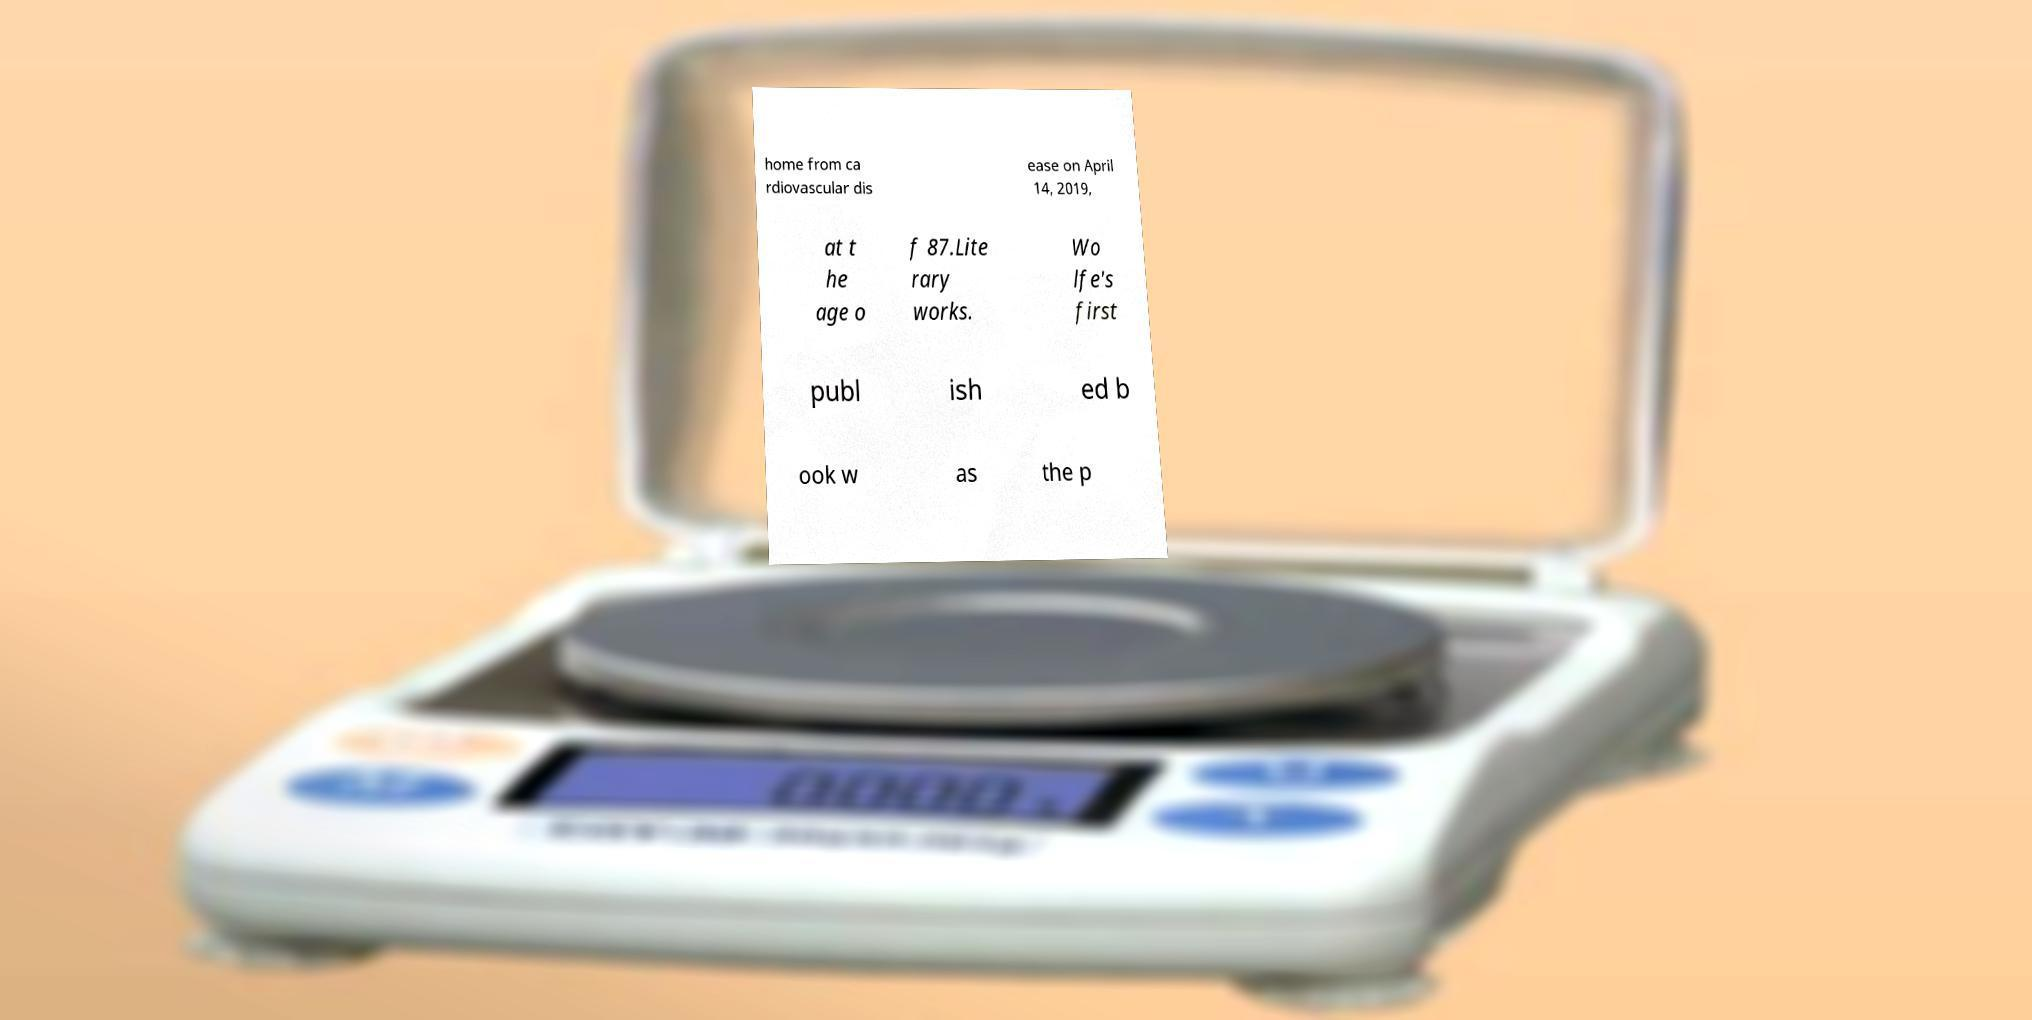Please identify and transcribe the text found in this image. home from ca rdiovascular dis ease on April 14, 2019, at t he age o f 87.Lite rary works. Wo lfe's first publ ish ed b ook w as the p 